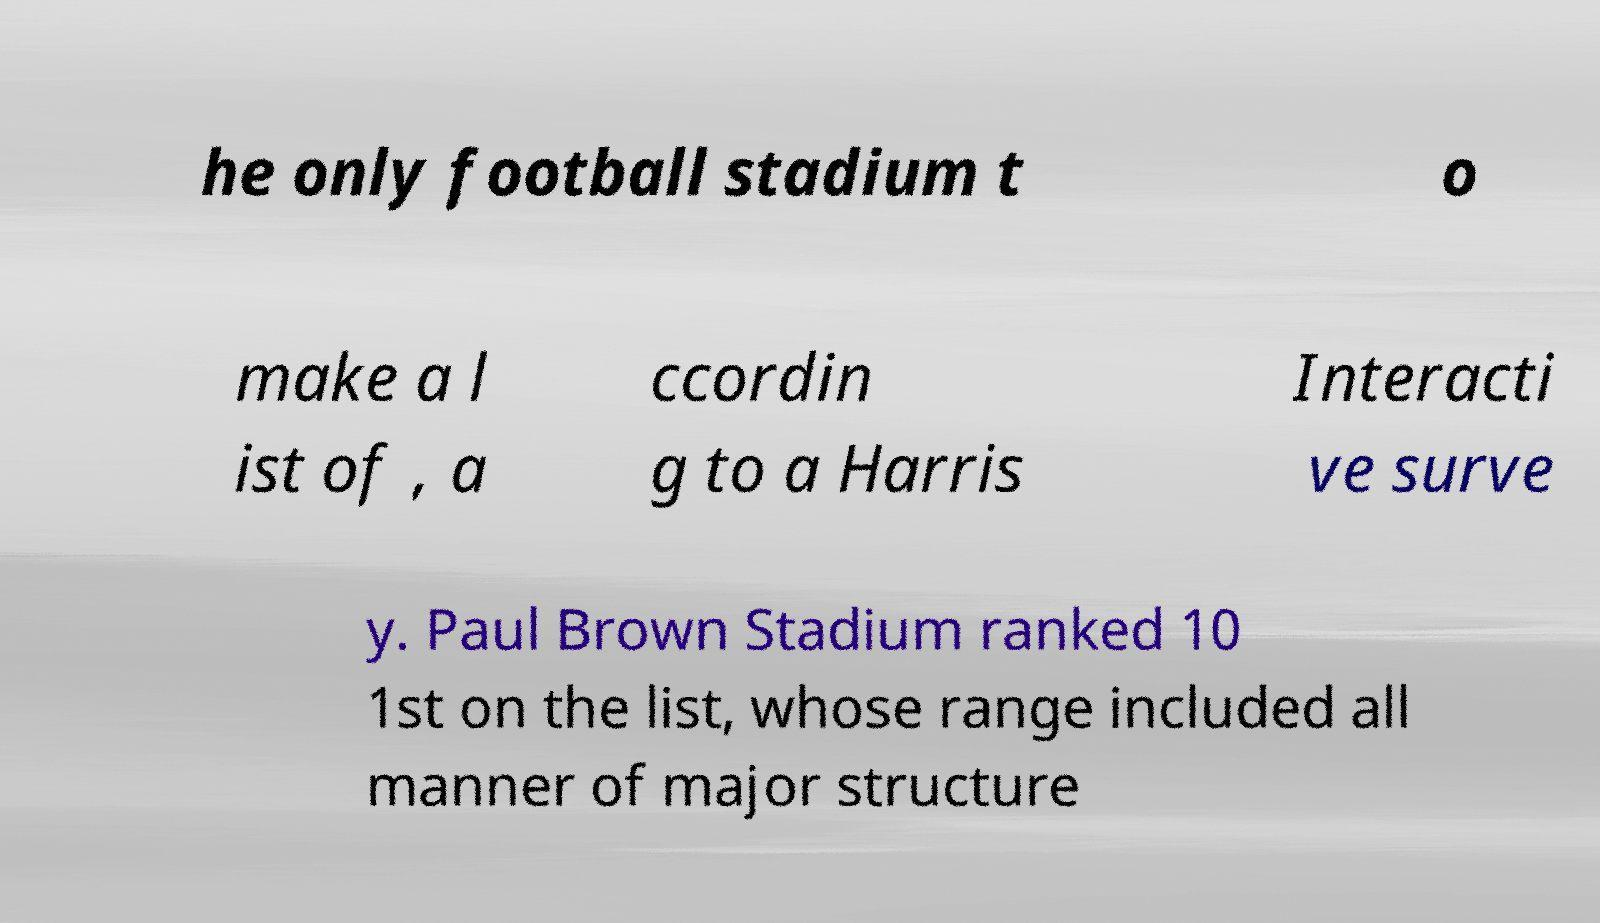What messages or text are displayed in this image? I need them in a readable, typed format. he only football stadium t o make a l ist of , a ccordin g to a Harris Interacti ve surve y. Paul Brown Stadium ranked 10 1st on the list, whose range included all manner of major structure 